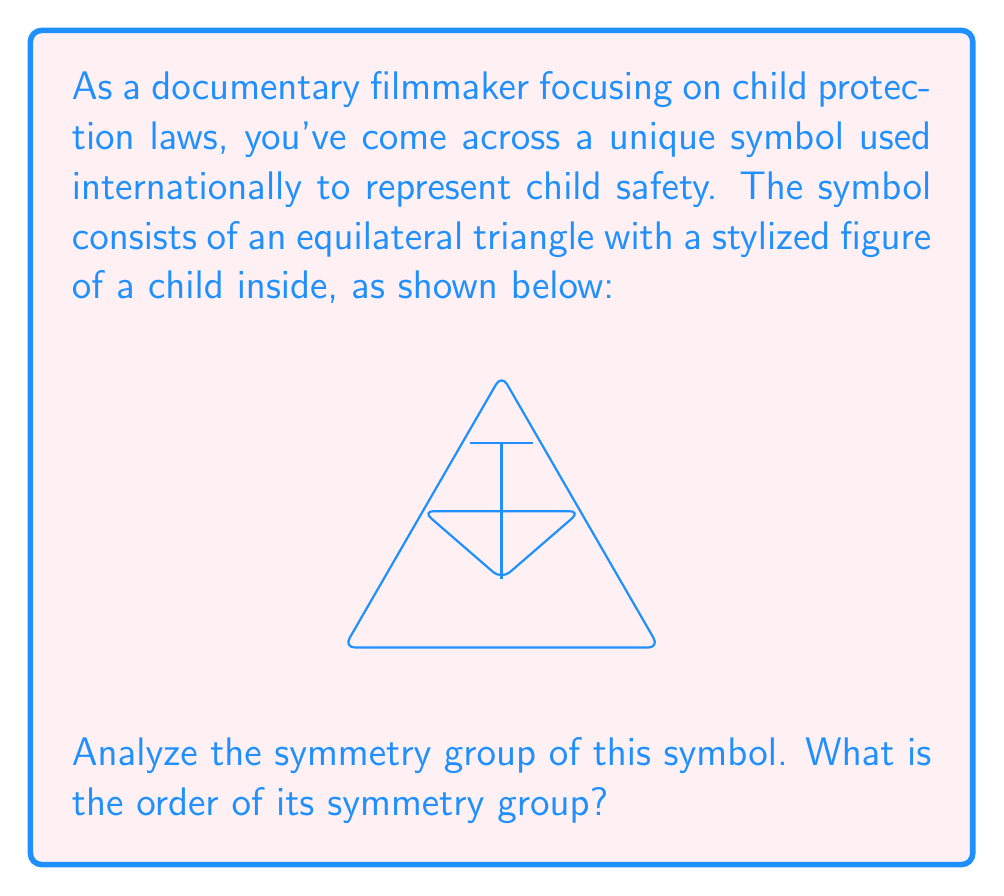Can you answer this question? To analyze the symmetry group of this symbol, we need to consider all the symmetries that preserve the shape. Let's approach this step-by-step:

1) First, we identify the symmetries:
   a) Rotational symmetries: The equilateral triangle has 3-fold rotational symmetry (120° rotations).
   b) Reflection symmetries: There are 3 lines of reflection, one through each vertex to the midpoint of the opposite side.

2) Let's count these symmetries:
   a) Rotations: 
      - Identity (0° rotation)
      - 120° clockwise rotation
      - 240° clockwise rotation (or 120° counterclockwise)
   b) Reflections:
      - Reflection across the vertical axis
      - Reflection across the axis from bottom left to top right
      - Reflection across the axis from bottom right to top left

3) In total, we have 6 symmetries: 3 rotations and 3 reflections.

4) These symmetries form a group under composition. This group is isomorphic to $D_3$, the dihedral group of order 6.

5) The order of a group is the number of elements in the group. Therefore, the order of this symmetry group is 6.

In abstract algebra terms, we can represent this group as:

$$ G = \{e, r, r^2, s, rs, r^2s\} $$

Where $e$ is the identity, $r$ is a 120° rotation, and $s$ is a reflection.
Answer: 6 